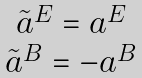<formula> <loc_0><loc_0><loc_500><loc_500>\begin{array} { c } \tilde { a } ^ { E } = a ^ { E } \\ \tilde { a } ^ { B } = - a ^ { B } \end{array}</formula> 